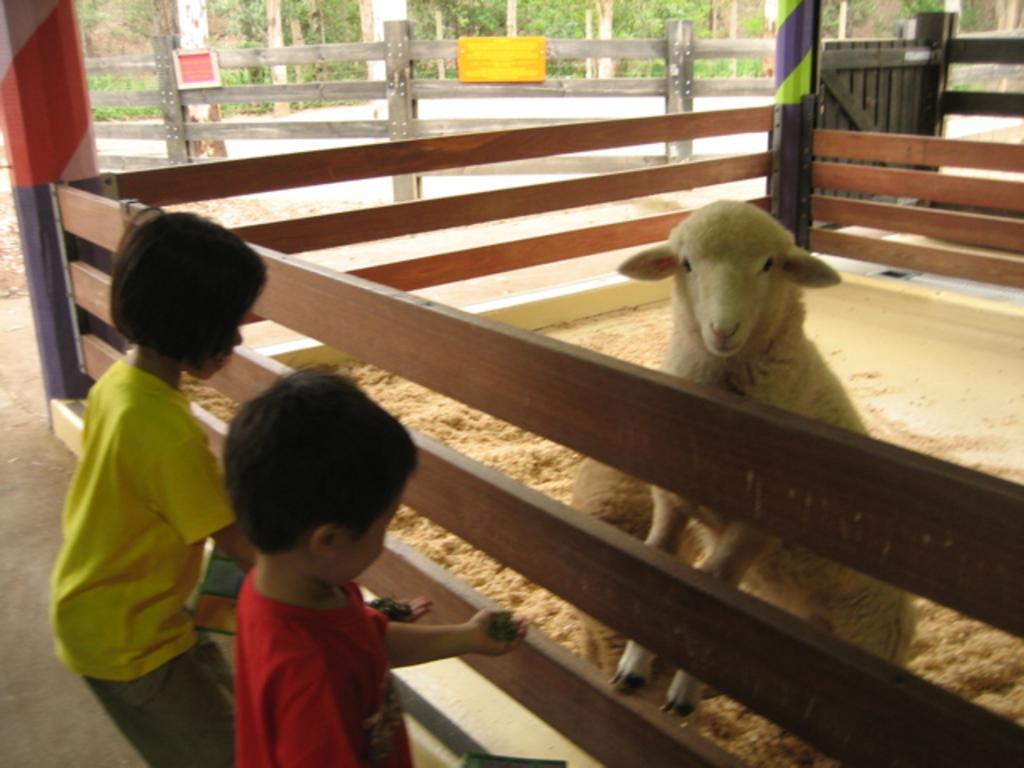How would you summarize this image in a sentence or two? On the left side, we see a girl in yellow T-shirt and a boy in the red T-shirt are standing. In front of them, we see a wooden fence. In the middle, we see a sheep. In the left top, we see a pillar in red, white and blue color. In the background, we see the trees, wooden fence and the boards in yellow and red color with come text written on it. On the right side, we see the wooden gate and a pillar in blue and green color. 